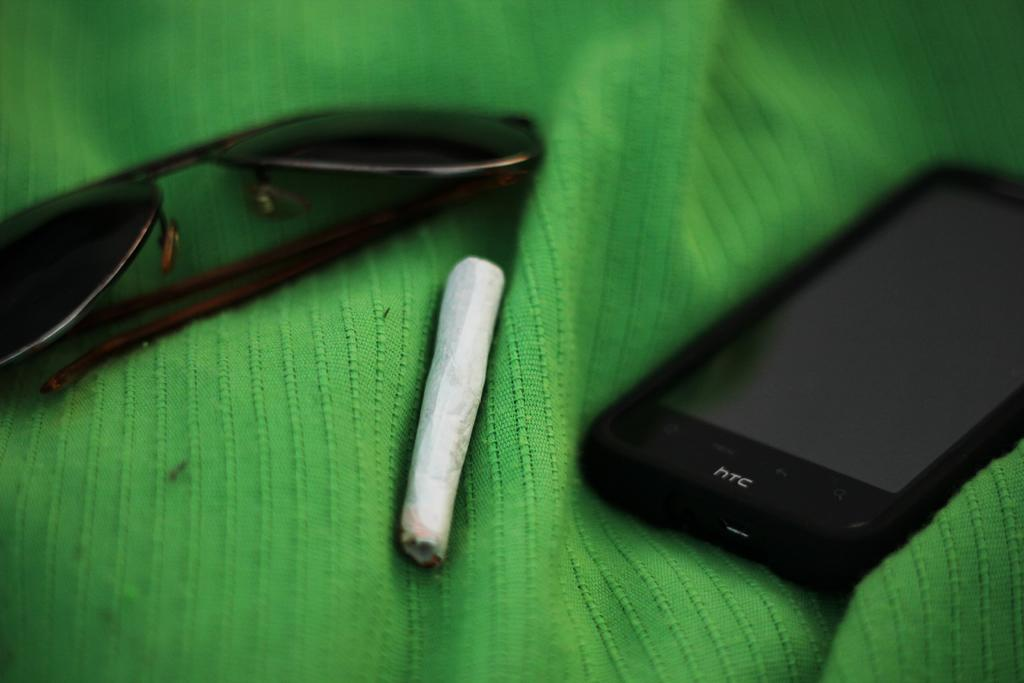What is the main object in the image? There is a mobile in the image. What else can be seen in the image besides the mobile? There are glasses in the image. Can you describe the object on the green cloth? There is an object on a green cloth in the image. How does the mobile contribute to the digestion process in the image? The mobile does not contribute to the digestion process in the image, as it is an inanimate object and not related to digestion. 